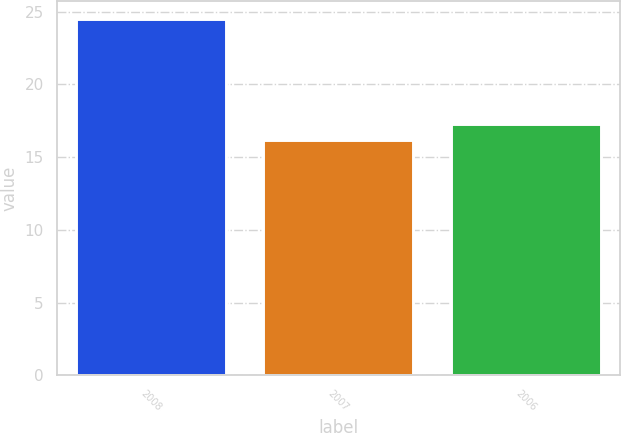<chart> <loc_0><loc_0><loc_500><loc_500><bar_chart><fcel>2008<fcel>2007<fcel>2006<nl><fcel>24.5<fcel>16.2<fcel>17.3<nl></chart> 